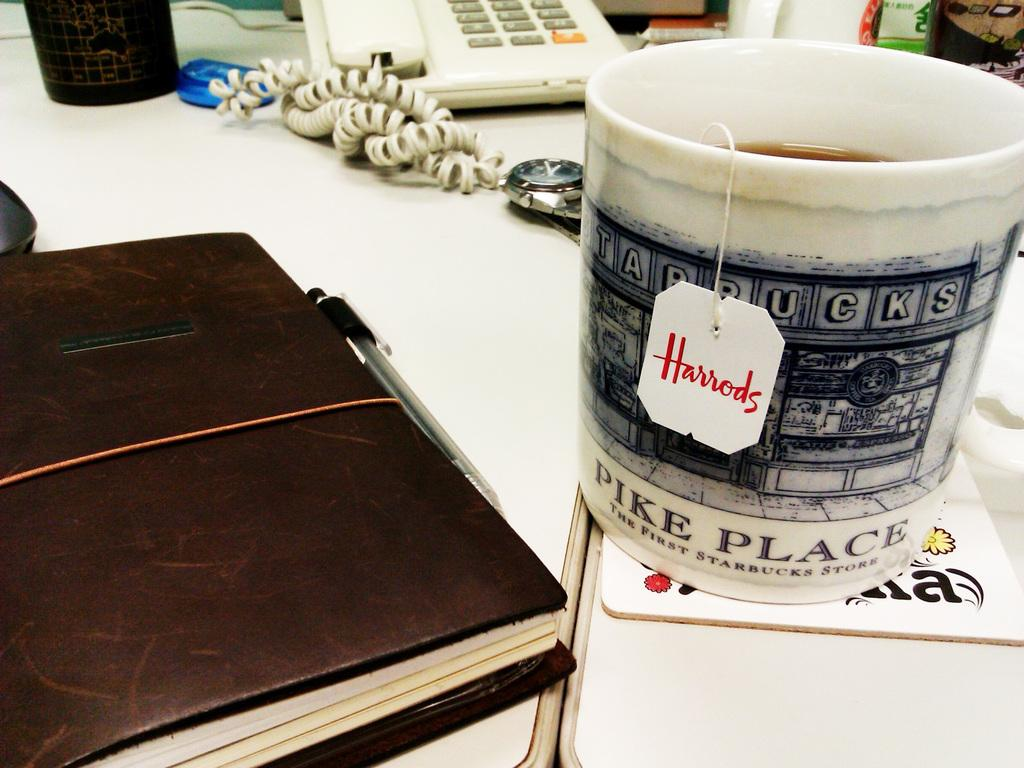Provide a one-sentence caption for the provided image. A mug from the Pike Place Starbucks sitting next to a leather bound book on a table. 